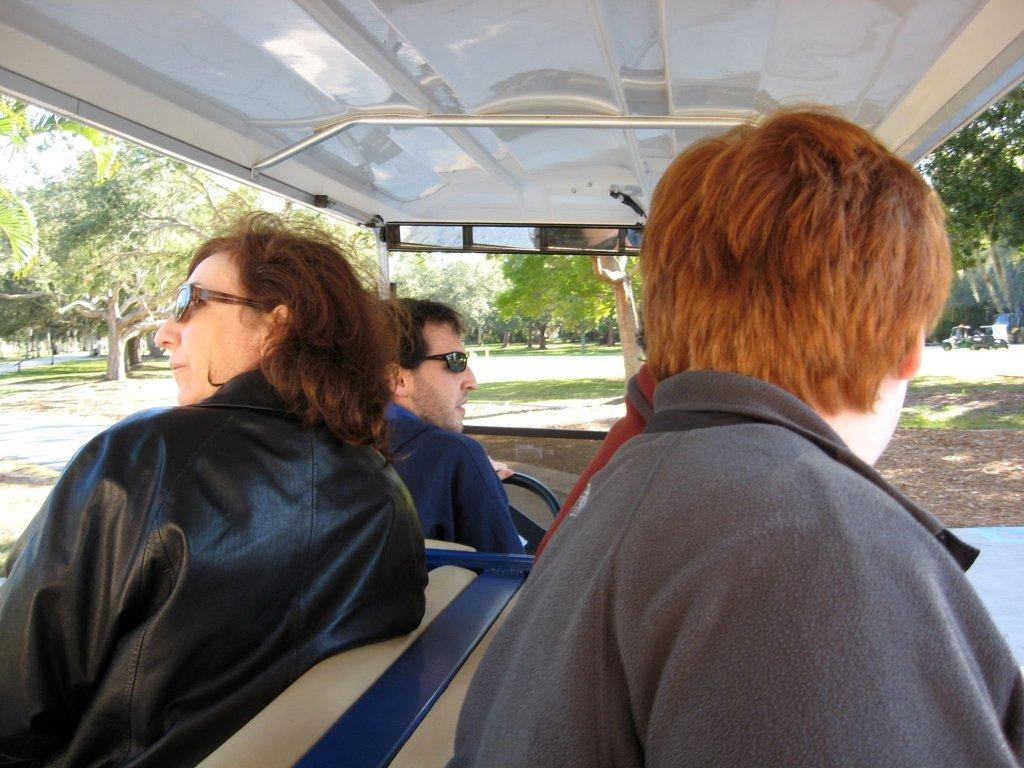How many people are in the image? There are three people in the image. What are the people doing in the image? The people are sitting in a vehicle. What are the people wearing in the image? The people are wearing coats. How many people are wearing sunglasses in the image? Two of the people are wearing sunglasses. What book is the person in the middle reading in the image? There is no book present in the image, so it cannot be determined what book the person might be reading. 